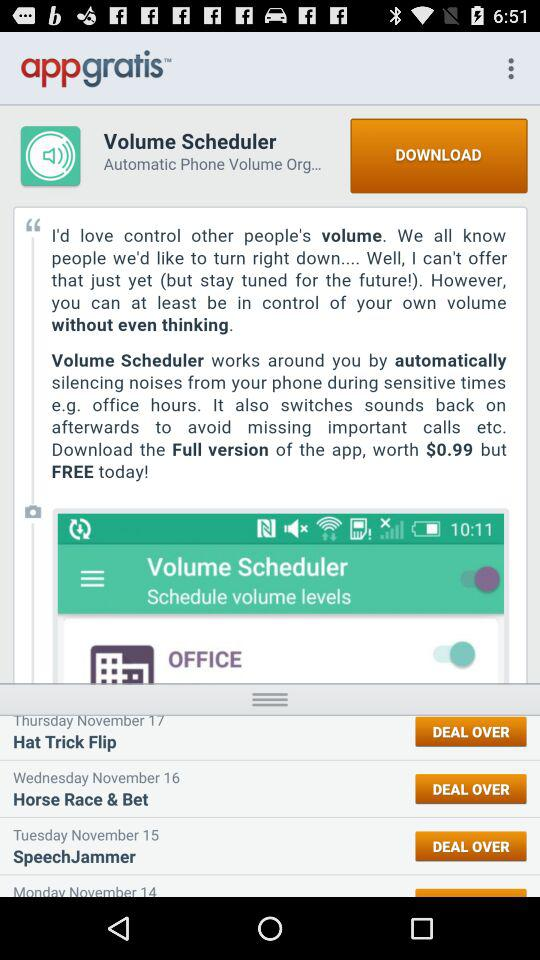What is the application name? The application names are "appgratis" and "Volume Scheduler". 